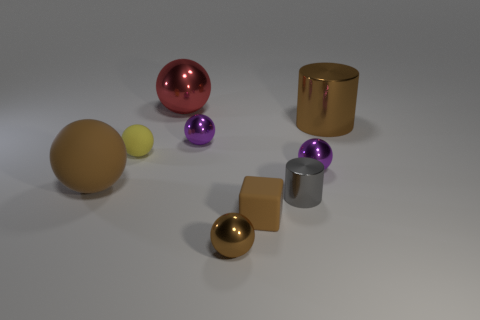What is the material of the big brown object that is the same shape as the large red object?
Provide a short and direct response. Rubber. Does the small brown ball have the same material as the tiny yellow object?
Offer a very short reply. No. Are there the same number of metal objects to the right of the gray metallic thing and yellow matte objects that are in front of the tiny brown rubber block?
Your answer should be very brief. No. There is a big metal object behind the brown thing that is right of the tiny cube; is there a red sphere that is in front of it?
Give a very brief answer. No. Do the brown block and the brown matte ball have the same size?
Offer a terse response. No. There is a big ball to the left of the big metallic thing that is on the left side of the brown thing that is behind the big matte thing; what is its color?
Provide a succinct answer. Brown. How many small balls are the same color as the big rubber thing?
Keep it short and to the point. 1. What number of big things are either rubber things or brown shiny cylinders?
Make the answer very short. 2. Are there any other tiny gray objects of the same shape as the gray metallic object?
Offer a very short reply. No. Is the large brown matte thing the same shape as the gray object?
Your answer should be compact. No. 